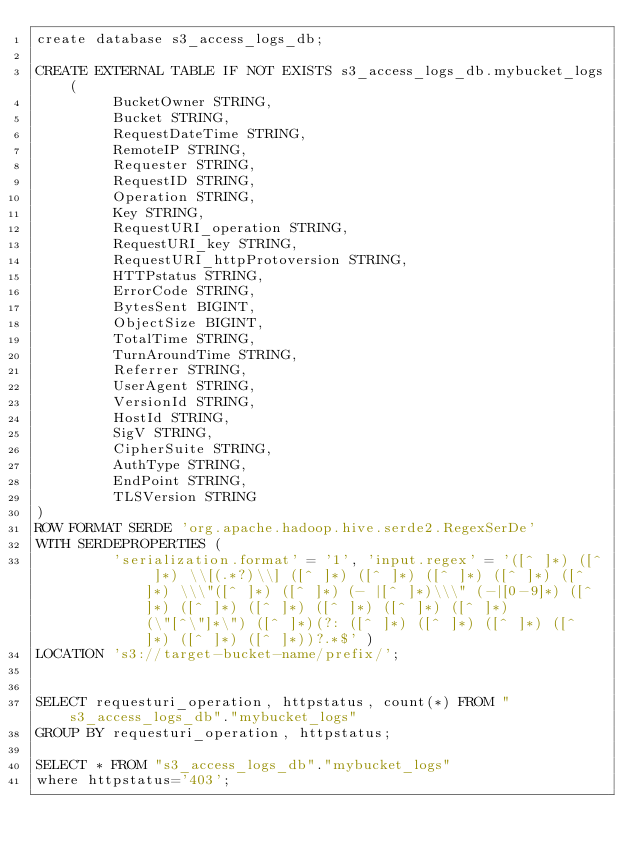Convert code to text. <code><loc_0><loc_0><loc_500><loc_500><_SQL_>create database s3_access_logs_db;

CREATE EXTERNAL TABLE IF NOT EXISTS s3_access_logs_db.mybucket_logs(
         BucketOwner STRING,
         Bucket STRING,
         RequestDateTime STRING,
         RemoteIP STRING,
         Requester STRING,
         RequestID STRING,
         Operation STRING,
         Key STRING,
         RequestURI_operation STRING,
         RequestURI_key STRING,
         RequestURI_httpProtoversion STRING,
         HTTPstatus STRING,
         ErrorCode STRING,
         BytesSent BIGINT,
         ObjectSize BIGINT,
         TotalTime STRING,
         TurnAroundTime STRING,
         Referrer STRING,
         UserAgent STRING,
         VersionId STRING,
         HostId STRING,
         SigV STRING,
         CipherSuite STRING,
         AuthType STRING,
         EndPoint STRING,
         TLSVersion STRING
) 
ROW FORMAT SERDE 'org.apache.hadoop.hive.serde2.RegexSerDe'
WITH SERDEPROPERTIES (
         'serialization.format' = '1', 'input.regex' = '([^ ]*) ([^ ]*) \\[(.*?)\\] ([^ ]*) ([^ ]*) ([^ ]*) ([^ ]*) ([^ ]*) \\\"([^ ]*) ([^ ]*) (- |[^ ]*)\\\" (-|[0-9]*) ([^ ]*) ([^ ]*) ([^ ]*) ([^ ]*) ([^ ]*) ([^ ]*) (\"[^\"]*\") ([^ ]*)(?: ([^ ]*) ([^ ]*) ([^ ]*) ([^ ]*) ([^ ]*) ([^ ]*))?.*$' )
LOCATION 's3://target-bucket-name/prefix/';


SELECT requesturi_operation, httpstatus, count(*) FROM "s3_access_logs_db"."mybucket_logs" 
GROUP BY requesturi_operation, httpstatus;

SELECT * FROM "s3_access_logs_db"."mybucket_logs"
where httpstatus='403';</code> 